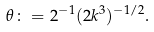<formula> <loc_0><loc_0><loc_500><loc_500>\theta \colon = 2 ^ { - 1 } ( 2 k ^ { 3 } ) ^ { - 1 / 2 } .</formula> 